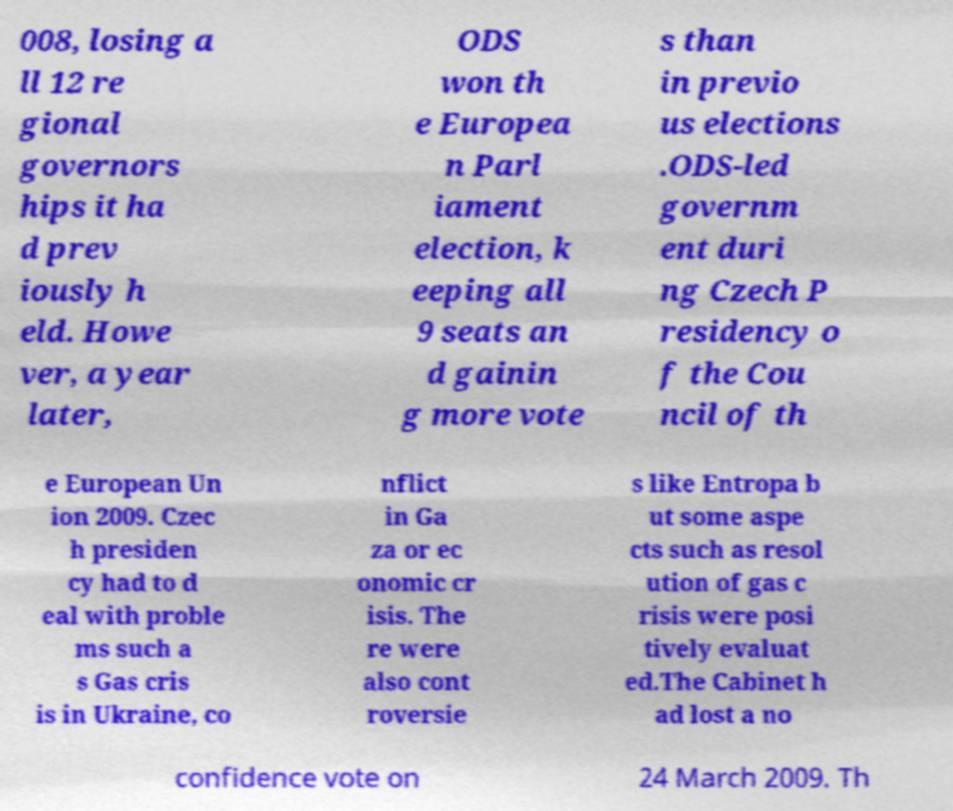I need the written content from this picture converted into text. Can you do that? 008, losing a ll 12 re gional governors hips it ha d prev iously h eld. Howe ver, a year later, ODS won th e Europea n Parl iament election, k eeping all 9 seats an d gainin g more vote s than in previo us elections .ODS-led governm ent duri ng Czech P residency o f the Cou ncil of th e European Un ion 2009. Czec h presiden cy had to d eal with proble ms such a s Gas cris is in Ukraine, co nflict in Ga za or ec onomic cr isis. The re were also cont roversie s like Entropa b ut some aspe cts such as resol ution of gas c risis were posi tively evaluat ed.The Cabinet h ad lost a no confidence vote on 24 March 2009. Th 